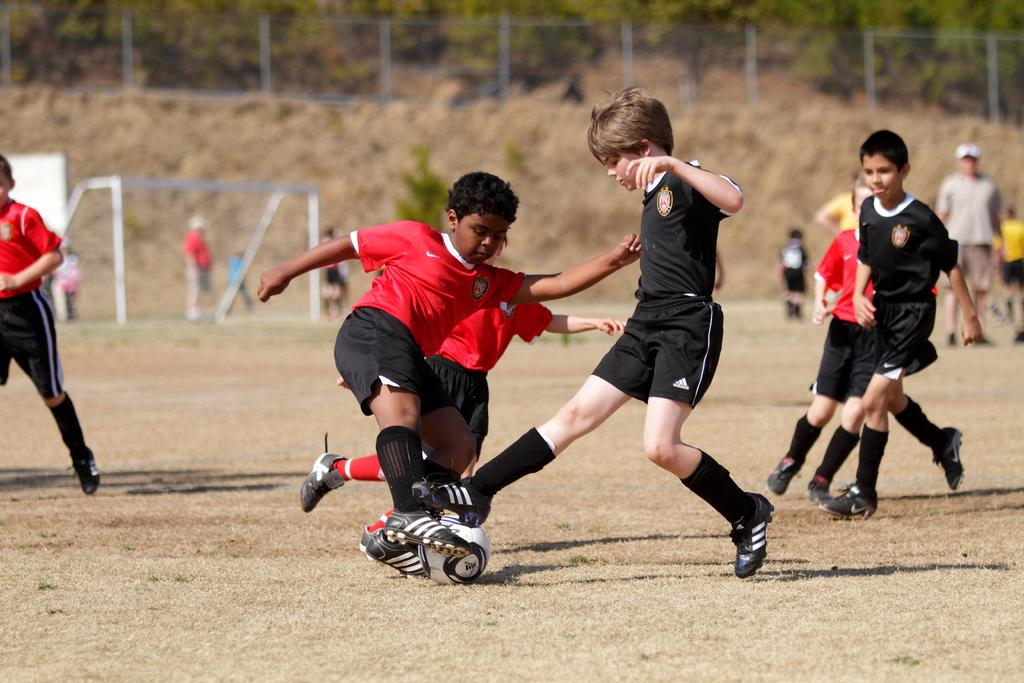What are the boys in the image doing? The boys in the image are playing with a ball. Can you describe the man in the background? There is a man wearing a cap in the background, watching the boys. What can be seen in the image that might be used to contain the ball? There is a football net in the image. What type of natural elements are visible in the background of the image? There are trees and a wall in the background of the image. What type of quince is being used as a ball by the boys in the image? There is no quince present in the image; the boys are playing with a regular ball. How many giants can be seen in the image? There are no giants present in the image. 